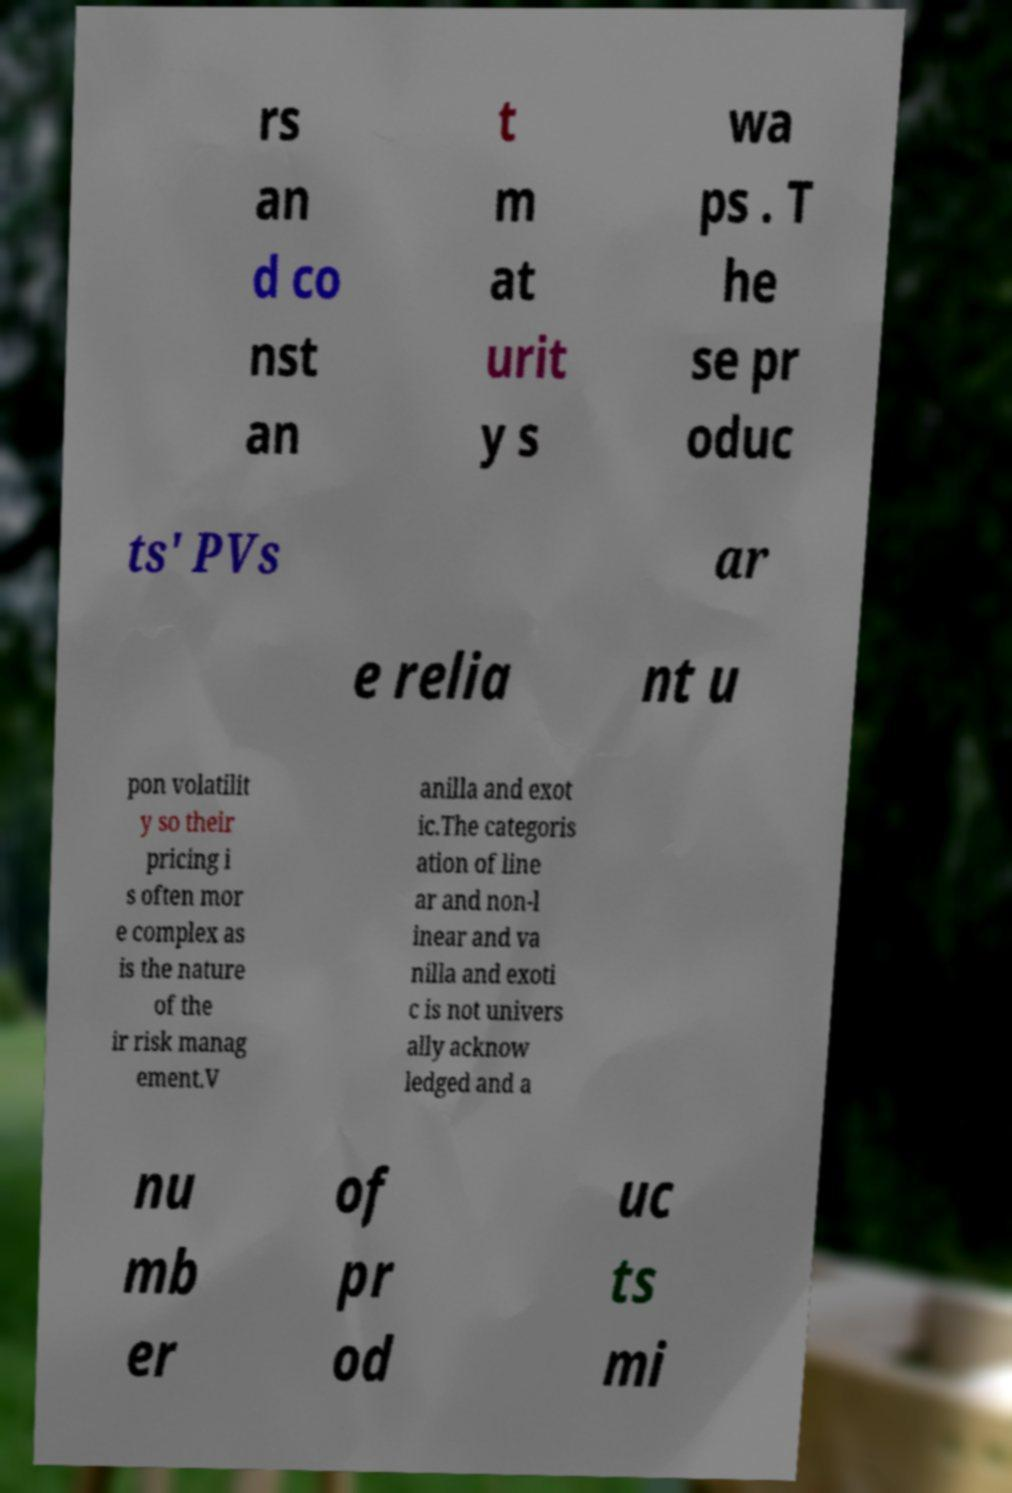Could you assist in decoding the text presented in this image and type it out clearly? rs an d co nst an t m at urit y s wa ps . T he se pr oduc ts' PVs ar e relia nt u pon volatilit y so their pricing i s often mor e complex as is the nature of the ir risk manag ement.V anilla and exot ic.The categoris ation of line ar and non-l inear and va nilla and exoti c is not univers ally acknow ledged and a nu mb er of pr od uc ts mi 